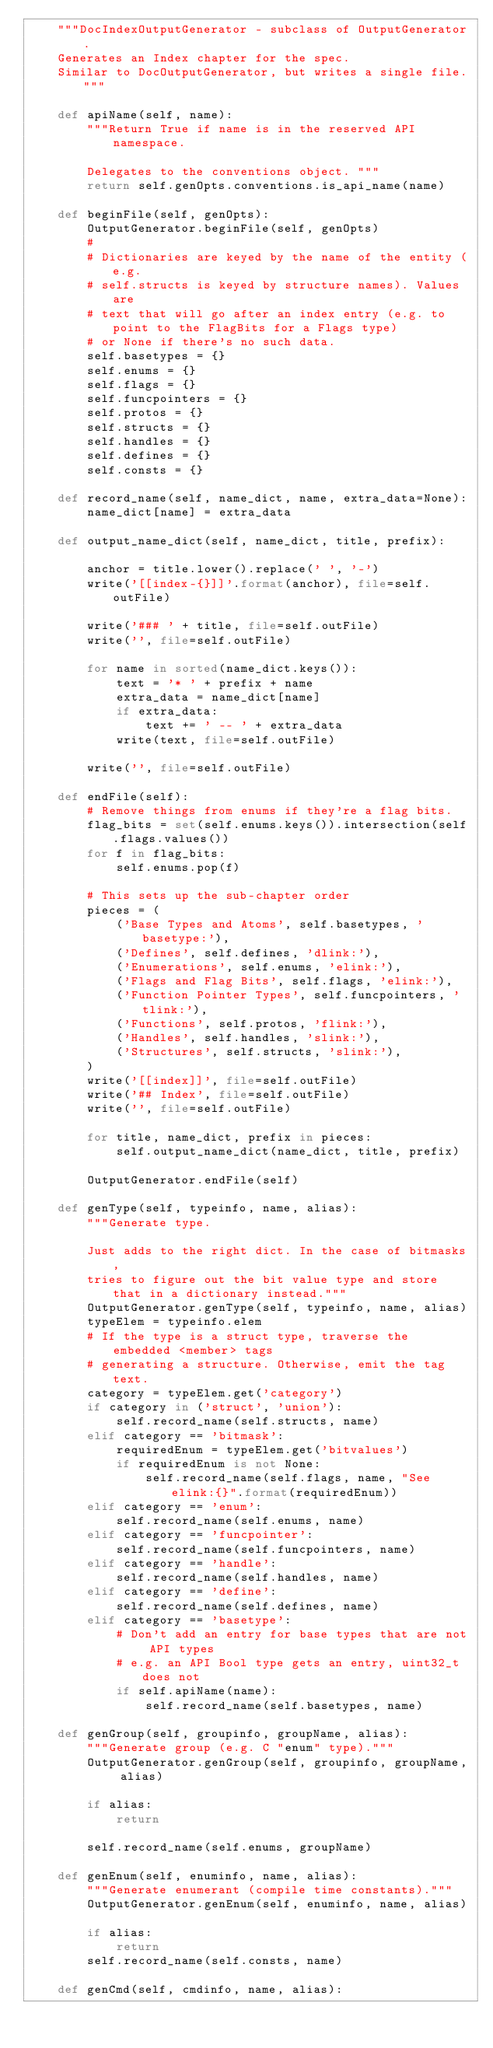<code> <loc_0><loc_0><loc_500><loc_500><_Python_>    """DocIndexOutputGenerator - subclass of OutputGenerator.
    Generates an Index chapter for the spec.
    Similar to DocOutputGenerator, but writes a single file."""

    def apiName(self, name):
        """Return True if name is in the reserved API namespace.

        Delegates to the conventions object. """
        return self.genOpts.conventions.is_api_name(name)

    def beginFile(self, genOpts):
        OutputGenerator.beginFile(self, genOpts)
        #
        # Dictionaries are keyed by the name of the entity (e.g.
        # self.structs is keyed by structure names). Values are
        # text that will go after an index entry (e.g. to point to the FlagBits for a Flags type)
        # or None if there's no such data.
        self.basetypes = {}
        self.enums = {}
        self.flags = {}
        self.funcpointers = {}
        self.protos = {}
        self.structs = {}
        self.handles = {}
        self.defines = {}
        self.consts = {}

    def record_name(self, name_dict, name, extra_data=None):
        name_dict[name] = extra_data

    def output_name_dict(self, name_dict, title, prefix):

        anchor = title.lower().replace(' ', '-')
        write('[[index-{}]]'.format(anchor), file=self.outFile)

        write('### ' + title, file=self.outFile)
        write('', file=self.outFile)

        for name in sorted(name_dict.keys()):
            text = '* ' + prefix + name
            extra_data = name_dict[name]
            if extra_data:
                text += ' -- ' + extra_data
            write(text, file=self.outFile)

        write('', file=self.outFile)

    def endFile(self):
        # Remove things from enums if they're a flag bits.
        flag_bits = set(self.enums.keys()).intersection(self.flags.values())
        for f in flag_bits:
            self.enums.pop(f)

        # This sets up the sub-chapter order
        pieces = (
            ('Base Types and Atoms', self.basetypes, 'basetype:'),
            ('Defines', self.defines, 'dlink:'),
            ('Enumerations', self.enums, 'elink:'),
            ('Flags and Flag Bits', self.flags, 'elink:'),
            ('Function Pointer Types', self.funcpointers, 'tlink:'),
            ('Functions', self.protos, 'flink:'),
            ('Handles', self.handles, 'slink:'),
            ('Structures', self.structs, 'slink:'),
        )
        write('[[index]]', file=self.outFile)
        write('## Index', file=self.outFile)
        write('', file=self.outFile)

        for title, name_dict, prefix in pieces:
            self.output_name_dict(name_dict, title, prefix)

        OutputGenerator.endFile(self)

    def genType(self, typeinfo, name, alias):
        """Generate type.

        Just adds to the right dict. In the case of bitmasks,
        tries to figure out the bit value type and store that in a dictionary instead."""
        OutputGenerator.genType(self, typeinfo, name, alias)
        typeElem = typeinfo.elem
        # If the type is a struct type, traverse the embedded <member> tags
        # generating a structure. Otherwise, emit the tag text.
        category = typeElem.get('category')
        if category in ('struct', 'union'):
            self.record_name(self.structs, name)
        elif category == 'bitmask':
            requiredEnum = typeElem.get('bitvalues')
            if requiredEnum is not None:
                self.record_name(self.flags, name, "See elink:{}".format(requiredEnum))
        elif category == 'enum':
            self.record_name(self.enums, name)
        elif category == 'funcpointer':
            self.record_name(self.funcpointers, name)
        elif category == 'handle':
            self.record_name(self.handles, name)
        elif category == 'define':
            self.record_name(self.defines, name)
        elif category == 'basetype':
            # Don't add an entry for base types that are not API types
            # e.g. an API Bool type gets an entry, uint32_t does not
            if self.apiName(name):
                self.record_name(self.basetypes, name)

    def genGroup(self, groupinfo, groupName, alias):
        """Generate group (e.g. C "enum" type)."""
        OutputGenerator.genGroup(self, groupinfo, groupName, alias)

        if alias:
            return

        self.record_name(self.enums, groupName)

    def genEnum(self, enuminfo, name, alias):
        """Generate enumerant (compile time constants)."""
        OutputGenerator.genEnum(self, enuminfo, name, alias)

        if alias:
            return
        self.record_name(self.consts, name)

    def genCmd(self, cmdinfo, name, alias):</code> 